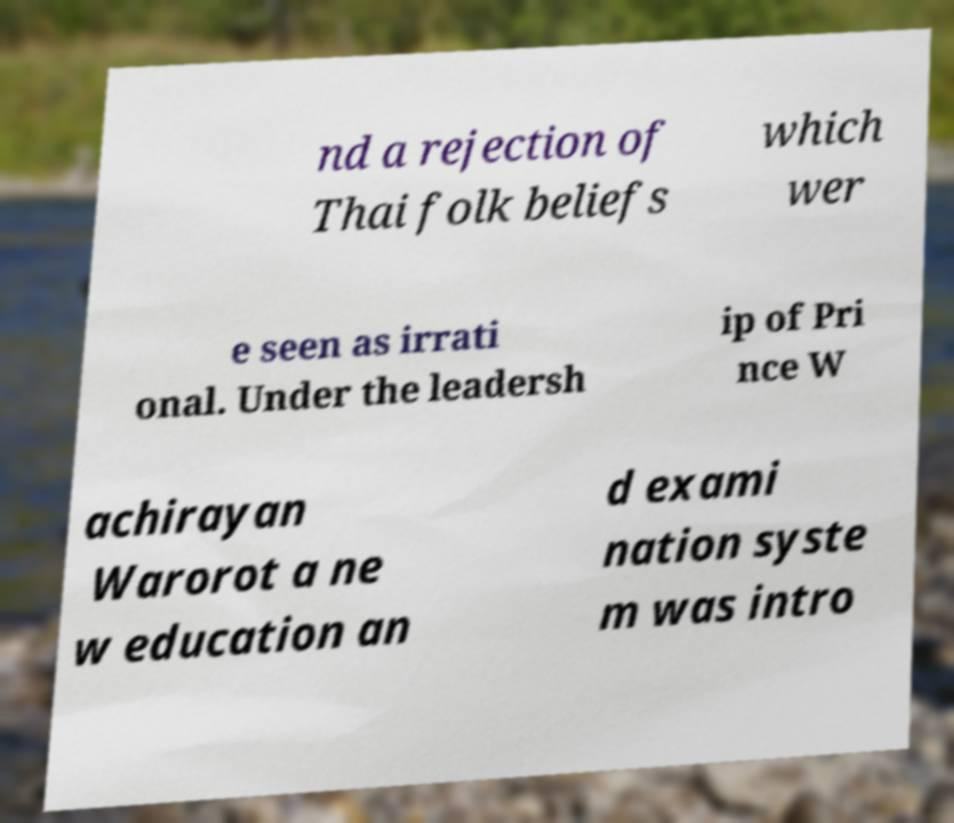Please identify and transcribe the text found in this image. nd a rejection of Thai folk beliefs which wer e seen as irrati onal. Under the leadersh ip of Pri nce W achirayan Warorot a ne w education an d exami nation syste m was intro 